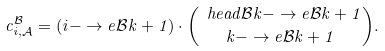<formula> <loc_0><loc_0><loc_500><loc_500>c ^ { \mathcal { B } } _ { i , { \mathcal { A } } } = ( i - \to e { { \mathcal { B } } } { k } + 1 ) \cdot \binom { \ h e a d { { \mathcal { B } } } { k } - \to e { { \mathcal { B } } } { k } + 1 } { k - \to e { { \mathcal { B } } } { k } + 1 } .</formula> 